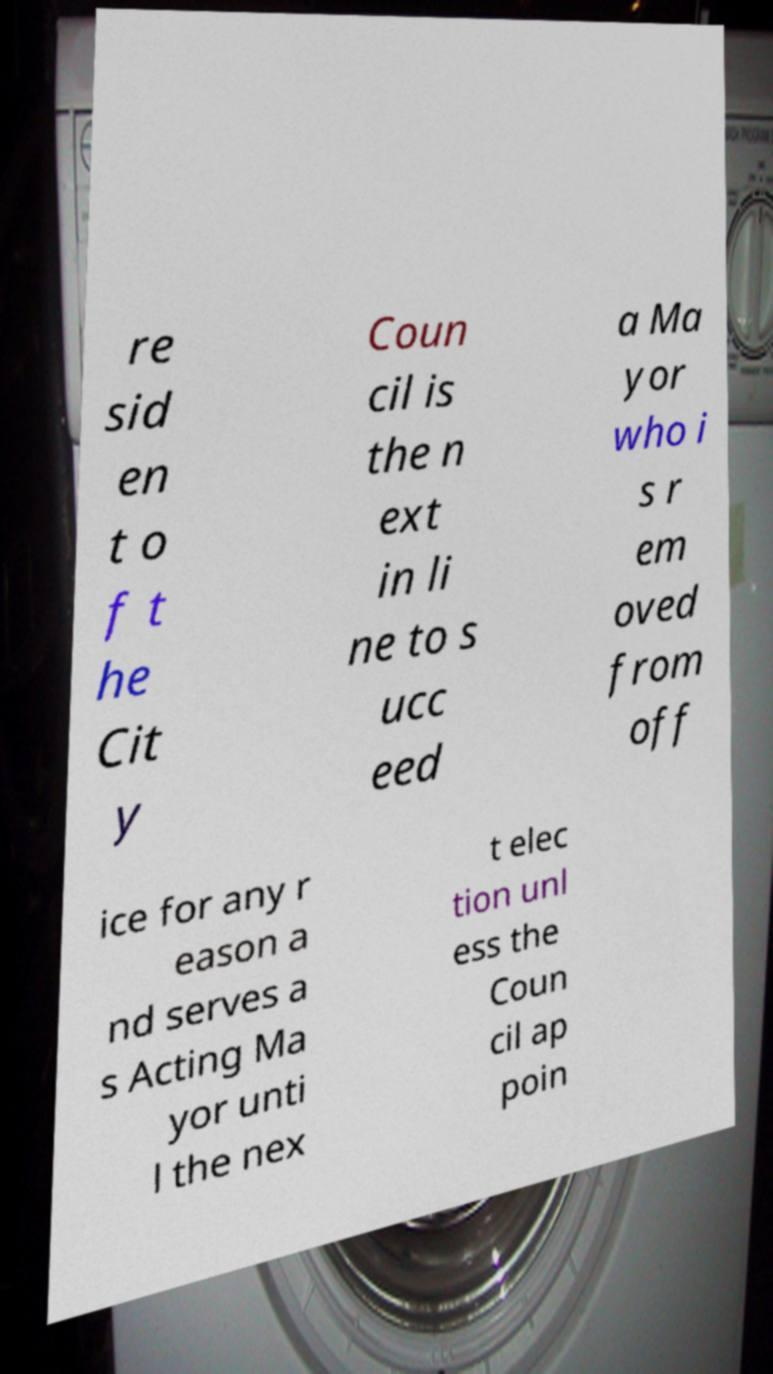There's text embedded in this image that I need extracted. Can you transcribe it verbatim? re sid en t o f t he Cit y Coun cil is the n ext in li ne to s ucc eed a Ma yor who i s r em oved from off ice for any r eason a nd serves a s Acting Ma yor unti l the nex t elec tion unl ess the Coun cil ap poin 